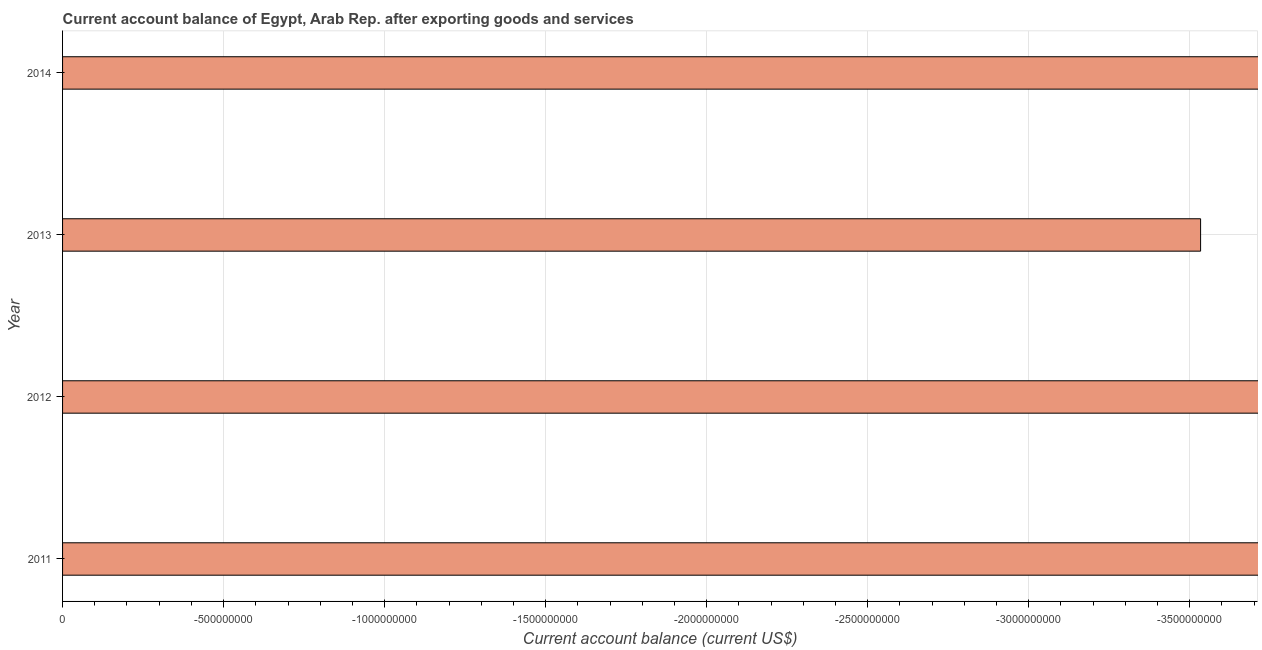Does the graph contain any zero values?
Ensure brevity in your answer.  Yes. Does the graph contain grids?
Provide a succinct answer. Yes. What is the title of the graph?
Give a very brief answer. Current account balance of Egypt, Arab Rep. after exporting goods and services. What is the label or title of the X-axis?
Offer a terse response. Current account balance (current US$). What is the label or title of the Y-axis?
Offer a terse response. Year. Across all years, what is the minimum current account balance?
Make the answer very short. 0. What is the sum of the current account balance?
Give a very brief answer. 0. What is the average current account balance per year?
Your response must be concise. 0. In how many years, is the current account balance greater than the average current account balance taken over all years?
Your answer should be very brief. 0. Are all the bars in the graph horizontal?
Provide a short and direct response. Yes. How many years are there in the graph?
Provide a succinct answer. 4. What is the difference between two consecutive major ticks on the X-axis?
Offer a terse response. 5.00e+08. What is the Current account balance (current US$) in 2013?
Give a very brief answer. 0. 